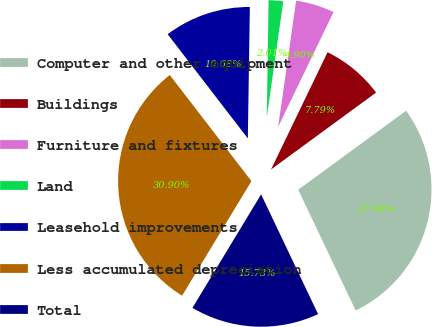<chart> <loc_0><loc_0><loc_500><loc_500><pie_chart><fcel>Computer and other equipment<fcel>Buildings<fcel>Furniture and fixtures<fcel>Land<fcel>Leasehold improvements<fcel>Less accumulated depreciation<fcel>Total<nl><fcel>27.99%<fcel>7.79%<fcel>4.9%<fcel>2.01%<fcel>10.68%<fcel>30.9%<fcel>15.73%<nl></chart> 